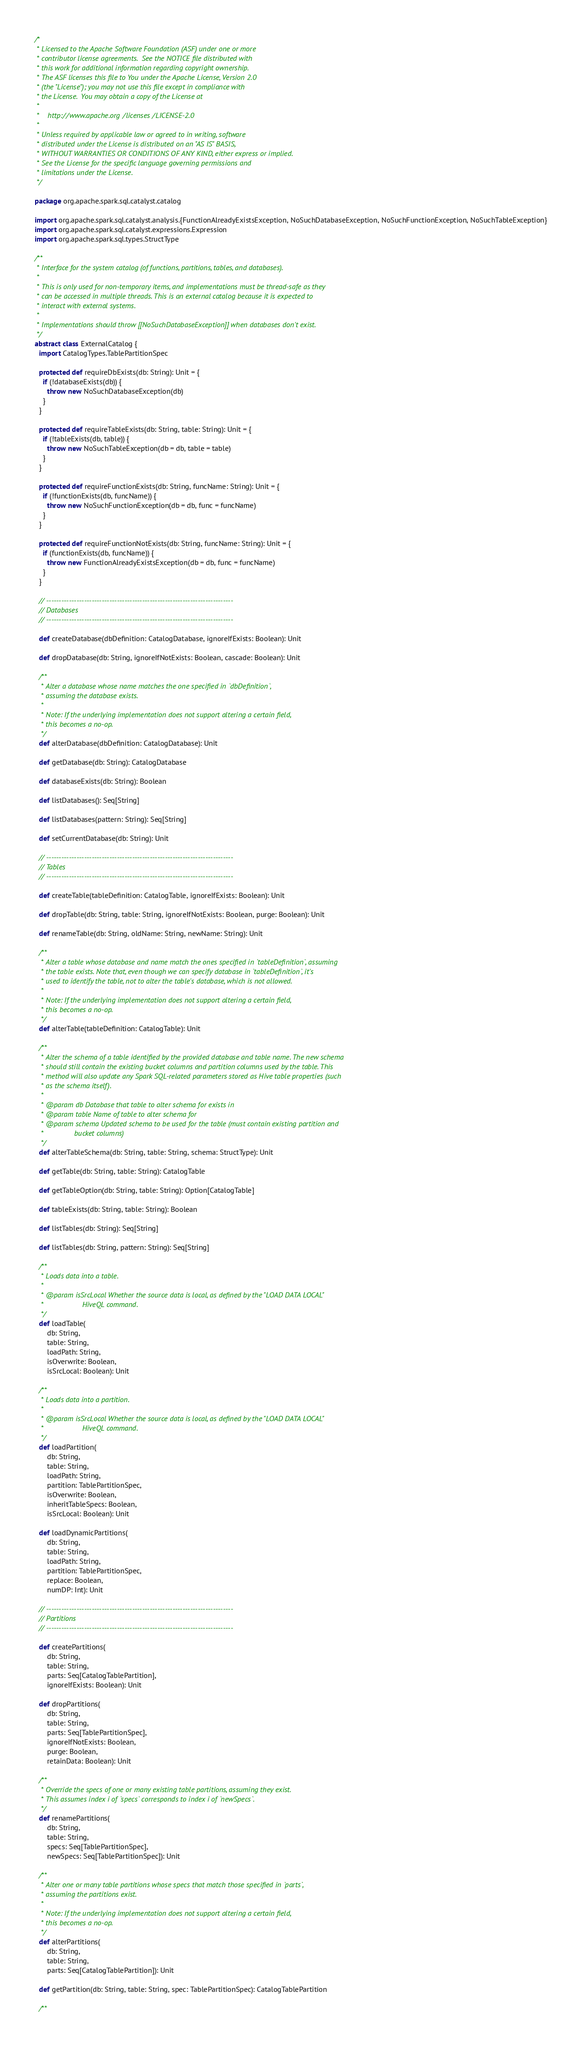Convert code to text. <code><loc_0><loc_0><loc_500><loc_500><_Scala_>/*
 * Licensed to the Apache Software Foundation (ASF) under one or more
 * contributor license agreements.  See the NOTICE file distributed with
 * this work for additional information regarding copyright ownership.
 * The ASF licenses this file to You under the Apache License, Version 2.0
 * (the "License"); you may not use this file except in compliance with
 * the License.  You may obtain a copy of the License at
 *
 *    http://www.apache.org/licenses/LICENSE-2.0
 *
 * Unless required by applicable law or agreed to in writing, software
 * distributed under the License is distributed on an "AS IS" BASIS,
 * WITHOUT WARRANTIES OR CONDITIONS OF ANY KIND, either express or implied.
 * See the License for the specific language governing permissions and
 * limitations under the License.
 */

package org.apache.spark.sql.catalyst.catalog

import org.apache.spark.sql.catalyst.analysis.{FunctionAlreadyExistsException, NoSuchDatabaseException, NoSuchFunctionException, NoSuchTableException}
import org.apache.spark.sql.catalyst.expressions.Expression
import org.apache.spark.sql.types.StructType

/**
 * Interface for the system catalog (of functions, partitions, tables, and databases).
 *
 * This is only used for non-temporary items, and implementations must be thread-safe as they
 * can be accessed in multiple threads. This is an external catalog because it is expected to
 * interact with external systems.
 *
 * Implementations should throw [[NoSuchDatabaseException]] when databases don't exist.
 */
abstract class ExternalCatalog {
  import CatalogTypes.TablePartitionSpec

  protected def requireDbExists(db: String): Unit = {
    if (!databaseExists(db)) {
      throw new NoSuchDatabaseException(db)
    }
  }

  protected def requireTableExists(db: String, table: String): Unit = {
    if (!tableExists(db, table)) {
      throw new NoSuchTableException(db = db, table = table)
    }
  }

  protected def requireFunctionExists(db: String, funcName: String): Unit = {
    if (!functionExists(db, funcName)) {
      throw new NoSuchFunctionException(db = db, func = funcName)
    }
  }

  protected def requireFunctionNotExists(db: String, funcName: String): Unit = {
    if (functionExists(db, funcName)) {
      throw new FunctionAlreadyExistsException(db = db, func = funcName)
    }
  }

  // --------------------------------------------------------------------------
  // Databases
  // --------------------------------------------------------------------------

  def createDatabase(dbDefinition: CatalogDatabase, ignoreIfExists: Boolean): Unit

  def dropDatabase(db: String, ignoreIfNotExists: Boolean, cascade: Boolean): Unit

  /**
   * Alter a database whose name matches the one specified in `dbDefinition`,
   * assuming the database exists.
   *
   * Note: If the underlying implementation does not support altering a certain field,
   * this becomes a no-op.
   */
  def alterDatabase(dbDefinition: CatalogDatabase): Unit

  def getDatabase(db: String): CatalogDatabase

  def databaseExists(db: String): Boolean

  def listDatabases(): Seq[String]

  def listDatabases(pattern: String): Seq[String]

  def setCurrentDatabase(db: String): Unit

  // --------------------------------------------------------------------------
  // Tables
  // --------------------------------------------------------------------------

  def createTable(tableDefinition: CatalogTable, ignoreIfExists: Boolean): Unit

  def dropTable(db: String, table: String, ignoreIfNotExists: Boolean, purge: Boolean): Unit

  def renameTable(db: String, oldName: String, newName: String): Unit

  /**
   * Alter a table whose database and name match the ones specified in `tableDefinition`, assuming
   * the table exists. Note that, even though we can specify database in `tableDefinition`, it's
   * used to identify the table, not to alter the table's database, which is not allowed.
   *
   * Note: If the underlying implementation does not support altering a certain field,
   * this becomes a no-op.
   */
  def alterTable(tableDefinition: CatalogTable): Unit

  /**
   * Alter the schema of a table identified by the provided database and table name. The new schema
   * should still contain the existing bucket columns and partition columns used by the table. This
   * method will also update any Spark SQL-related parameters stored as Hive table properties (such
   * as the schema itself).
   *
   * @param db Database that table to alter schema for exists in
   * @param table Name of table to alter schema for
   * @param schema Updated schema to be used for the table (must contain existing partition and
   *               bucket columns)
   */
  def alterTableSchema(db: String, table: String, schema: StructType): Unit

  def getTable(db: String, table: String): CatalogTable

  def getTableOption(db: String, table: String): Option[CatalogTable]

  def tableExists(db: String, table: String): Boolean

  def listTables(db: String): Seq[String]

  def listTables(db: String, pattern: String): Seq[String]

  /**
   * Loads data into a table.
   *
   * @param isSrcLocal Whether the source data is local, as defined by the "LOAD DATA LOCAL"
   *                   HiveQL command.
   */
  def loadTable(
      db: String,
      table: String,
      loadPath: String,
      isOverwrite: Boolean,
      isSrcLocal: Boolean): Unit

  /**
   * Loads data into a partition.
   *
   * @param isSrcLocal Whether the source data is local, as defined by the "LOAD DATA LOCAL"
   *                   HiveQL command.
   */
  def loadPartition(
      db: String,
      table: String,
      loadPath: String,
      partition: TablePartitionSpec,
      isOverwrite: Boolean,
      inheritTableSpecs: Boolean,
      isSrcLocal: Boolean): Unit

  def loadDynamicPartitions(
      db: String,
      table: String,
      loadPath: String,
      partition: TablePartitionSpec,
      replace: Boolean,
      numDP: Int): Unit

  // --------------------------------------------------------------------------
  // Partitions
  // --------------------------------------------------------------------------

  def createPartitions(
      db: String,
      table: String,
      parts: Seq[CatalogTablePartition],
      ignoreIfExists: Boolean): Unit

  def dropPartitions(
      db: String,
      table: String,
      parts: Seq[TablePartitionSpec],
      ignoreIfNotExists: Boolean,
      purge: Boolean,
      retainData: Boolean): Unit

  /**
   * Override the specs of one or many existing table partitions, assuming they exist.
   * This assumes index i of `specs` corresponds to index i of `newSpecs`.
   */
  def renamePartitions(
      db: String,
      table: String,
      specs: Seq[TablePartitionSpec],
      newSpecs: Seq[TablePartitionSpec]): Unit

  /**
   * Alter one or many table partitions whose specs that match those specified in `parts`,
   * assuming the partitions exist.
   *
   * Note: If the underlying implementation does not support altering a certain field,
   * this becomes a no-op.
   */
  def alterPartitions(
      db: String,
      table: String,
      parts: Seq[CatalogTablePartition]): Unit

  def getPartition(db: String, table: String, spec: TablePartitionSpec): CatalogTablePartition

  /**</code> 